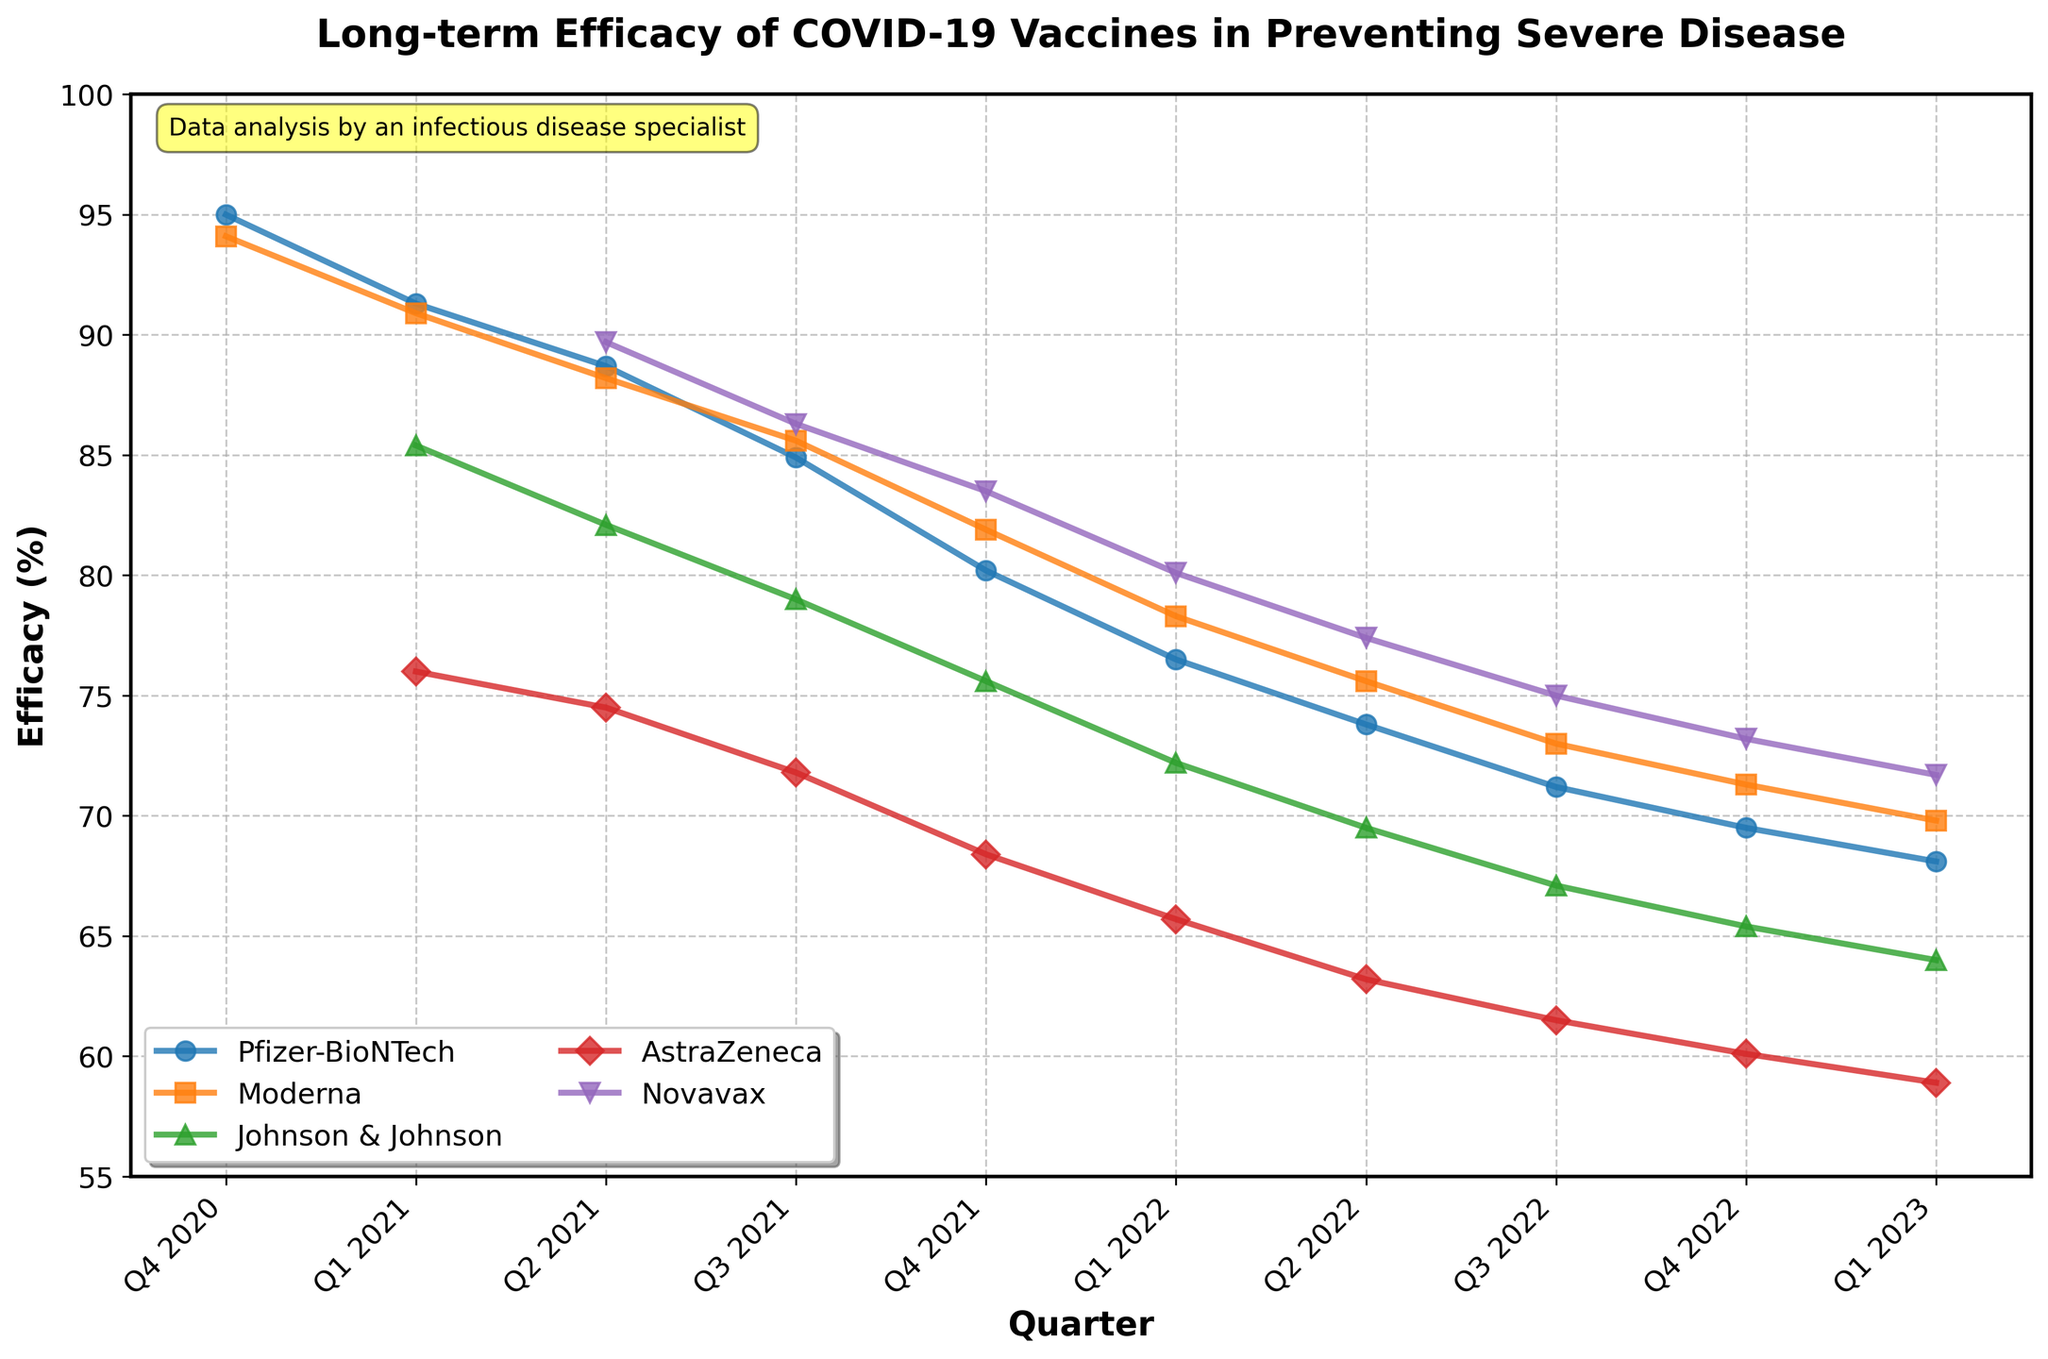Which vaccine showed the highest initial efficacy in Q4 2020? Looking at the plot for Q4 2020, the highest line represents Pfizer-BioNTech with an efficacy of 95.0%.
Answer: Pfizer-BioNTech Which vaccine showed the lowest efficacy in Q1 2023? Observing the plot for Q1 2023, AstraZeneca had the lowest efficacy at 58.9%.
Answer: AstraZeneca How did the efficacy of the Moderna vaccine change from Q1 2021 to Q1 2023? The efficacy of Moderna in Q1 2021 was 90.9%. By Q1 2023, it dropped to 69.8%. The change is 90.9% - 69.8% = 21.1% decrease.
Answer: Decreased by 21.1% Which two vaccines had the closest efficacy in Q2 2022? In Q2 2022, Pfizer-BioNTech had 73.8% and Moderna had 75.6%. The difference between them, 75.6% - 73.8% = 1.8%, is smaller than the differences between other vaccine pairs.
Answer: Pfizer-BioNTech and Moderna What is the average efficacy of Novavax over the available quarters? The efficacies of Novavax are: 89.7, 86.3, 83.5, 80.1, 77.4, 75.0, 73.2, and 71.7. Summing these gives 636.9. There are 8 data points, so the average is 636.9 / 8 = 79.6125.
Answer: 79.6% Which vaccine's efficacy declined the most from Q4 2020 to Q1 2023? By how much did it decline? Comparing the initial efficacy in Q4 2020 and the final efficacy in Q1 2023, Pfizer-BioNTech dropped from 95.0% to 68.1%, a decline of 95.0% - 68.1% = 26.9%. This is the largest decline among the vaccines.
Answer: Pfizer-BioNTech, decreased by 26.9% In Q4 2021, how many vaccines had an efficacy above 80%? Observing the plot in Q4 2021, Pfizer-BioNTech (80.2%) and Moderna (81.9%) were the only vaccines above 80%.
Answer: 2 Which vaccine exhibited a consistent decrease in efficacy each quarter from Q2 2021 to Q1 2023? Reviewing the plot, Johnson & Johnson consistently decreased each quarter from Q2 2021 (82.1%) to Q1 2023 (64.0%).
Answer: Johnson & Johnson What is the total decrease in efficacy for AstraZeneca from Q1 2021 to Q4 2022? AstraZeneca efficacy in Q1 2021 was 76.0%. By Q4 2022, it was 60.1%. The decrease is 76.0% - 60.1% = 15.9%.
Answer: 15.9% Which vaccine had the highest efficacy in Q2 2022? Observing Q2 2022, Novavax had the highest efficacy at 77.4%.
Answer: Novavax 